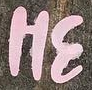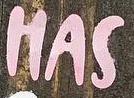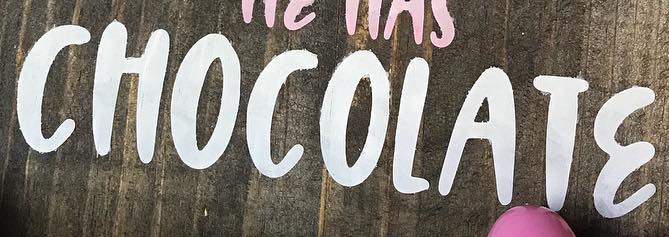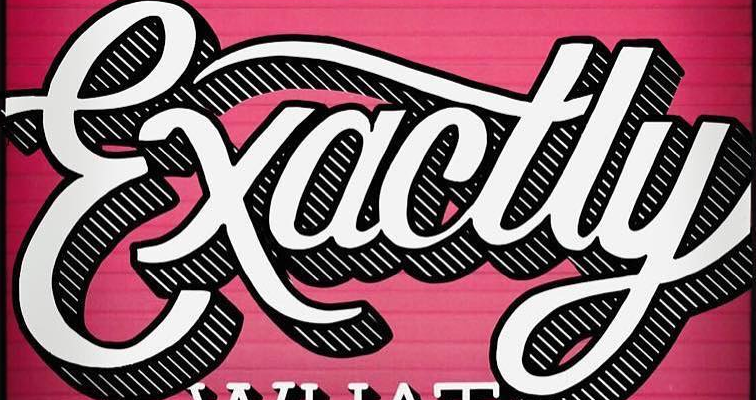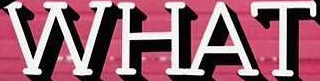What text appears in these images from left to right, separated by a semicolon? HƐ; HAS; CHOCOLATƐ; Exactly; WHAT 